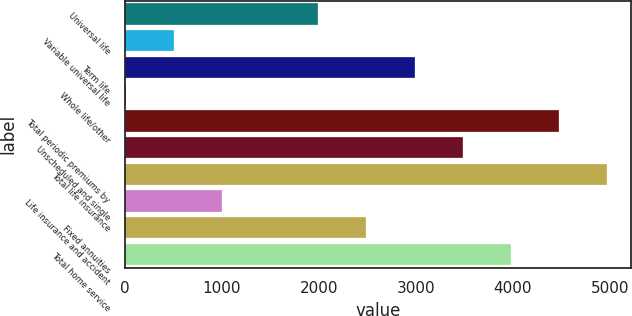Convert chart. <chart><loc_0><loc_0><loc_500><loc_500><bar_chart><fcel>Universal life<fcel>Variable universal life<fcel>Term life<fcel>Whole life/other<fcel>Total periodic premiums by<fcel>Unscheduled and single<fcel>Total life insurance<fcel>Life insurance and accident<fcel>Fixed annuities<fcel>Total home service<nl><fcel>1994.2<fcel>506.8<fcel>2985.8<fcel>11<fcel>4473.2<fcel>3481.6<fcel>4969<fcel>1002.6<fcel>2490<fcel>3977.4<nl></chart> 